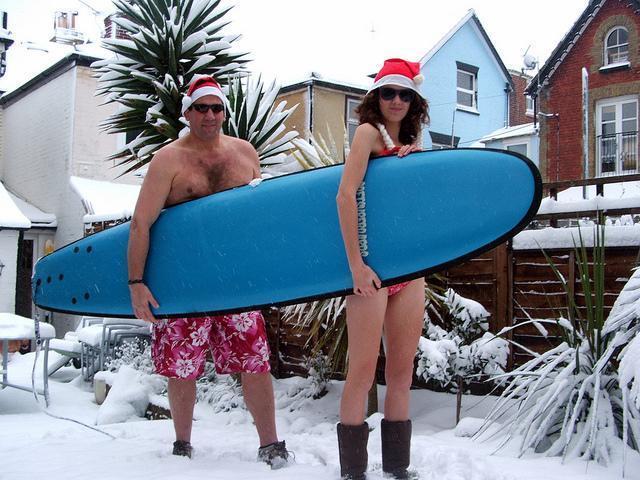How many people are visible?
Give a very brief answer. 2. How many green bikes are in the picture?
Give a very brief answer. 0. 